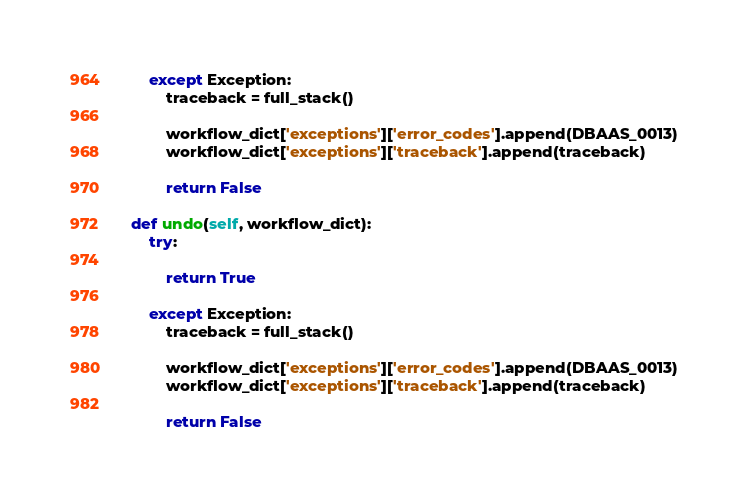Convert code to text. <code><loc_0><loc_0><loc_500><loc_500><_Python_>        except Exception:
            traceback = full_stack()

            workflow_dict['exceptions']['error_codes'].append(DBAAS_0013)
            workflow_dict['exceptions']['traceback'].append(traceback)

            return False

    def undo(self, workflow_dict):
        try:

            return True

        except Exception:
            traceback = full_stack()

            workflow_dict['exceptions']['error_codes'].append(DBAAS_0013)
            workflow_dict['exceptions']['traceback'].append(traceback)

            return False
</code> 